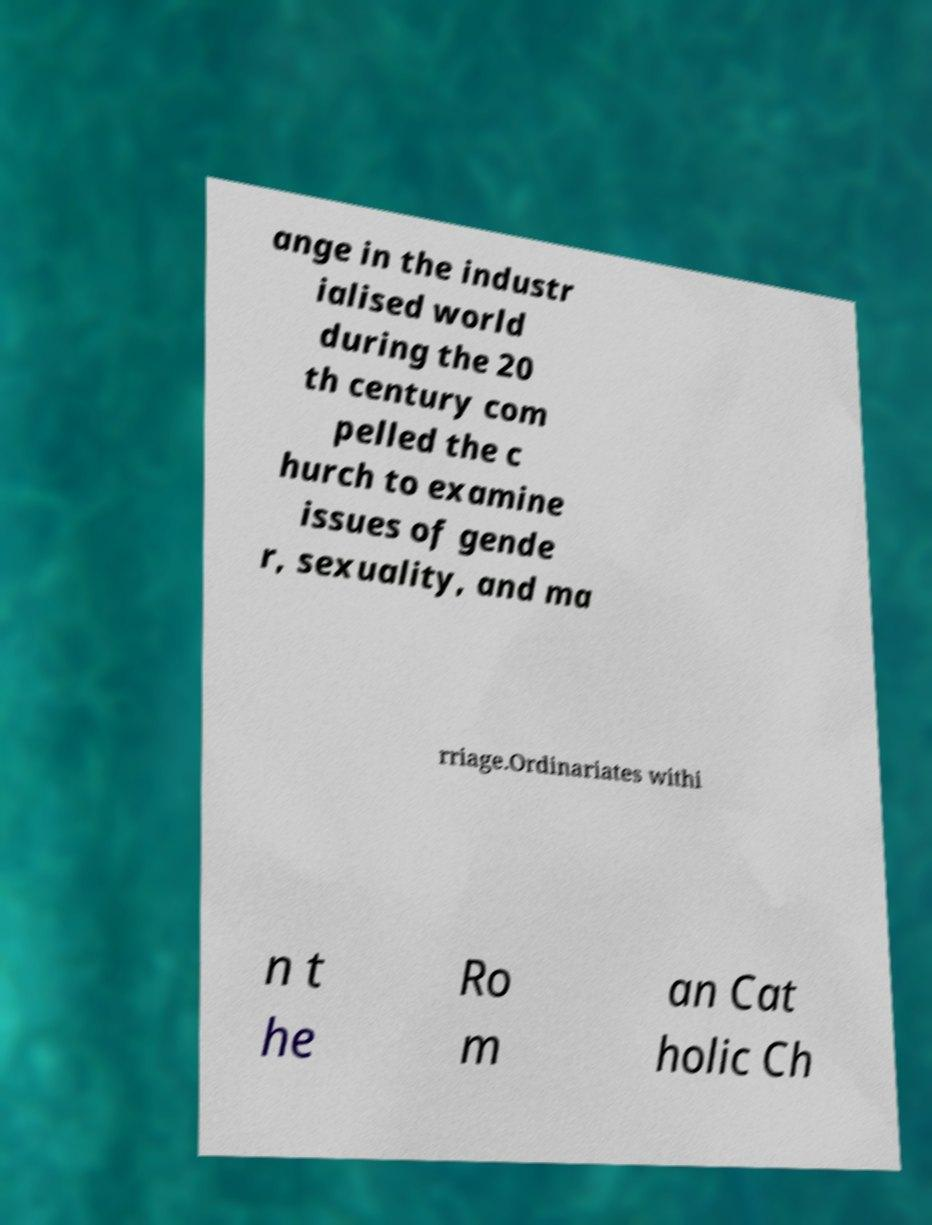There's text embedded in this image that I need extracted. Can you transcribe it verbatim? ange in the industr ialised world during the 20 th century com pelled the c hurch to examine issues of gende r, sexuality, and ma rriage.Ordinariates withi n t he Ro m an Cat holic Ch 